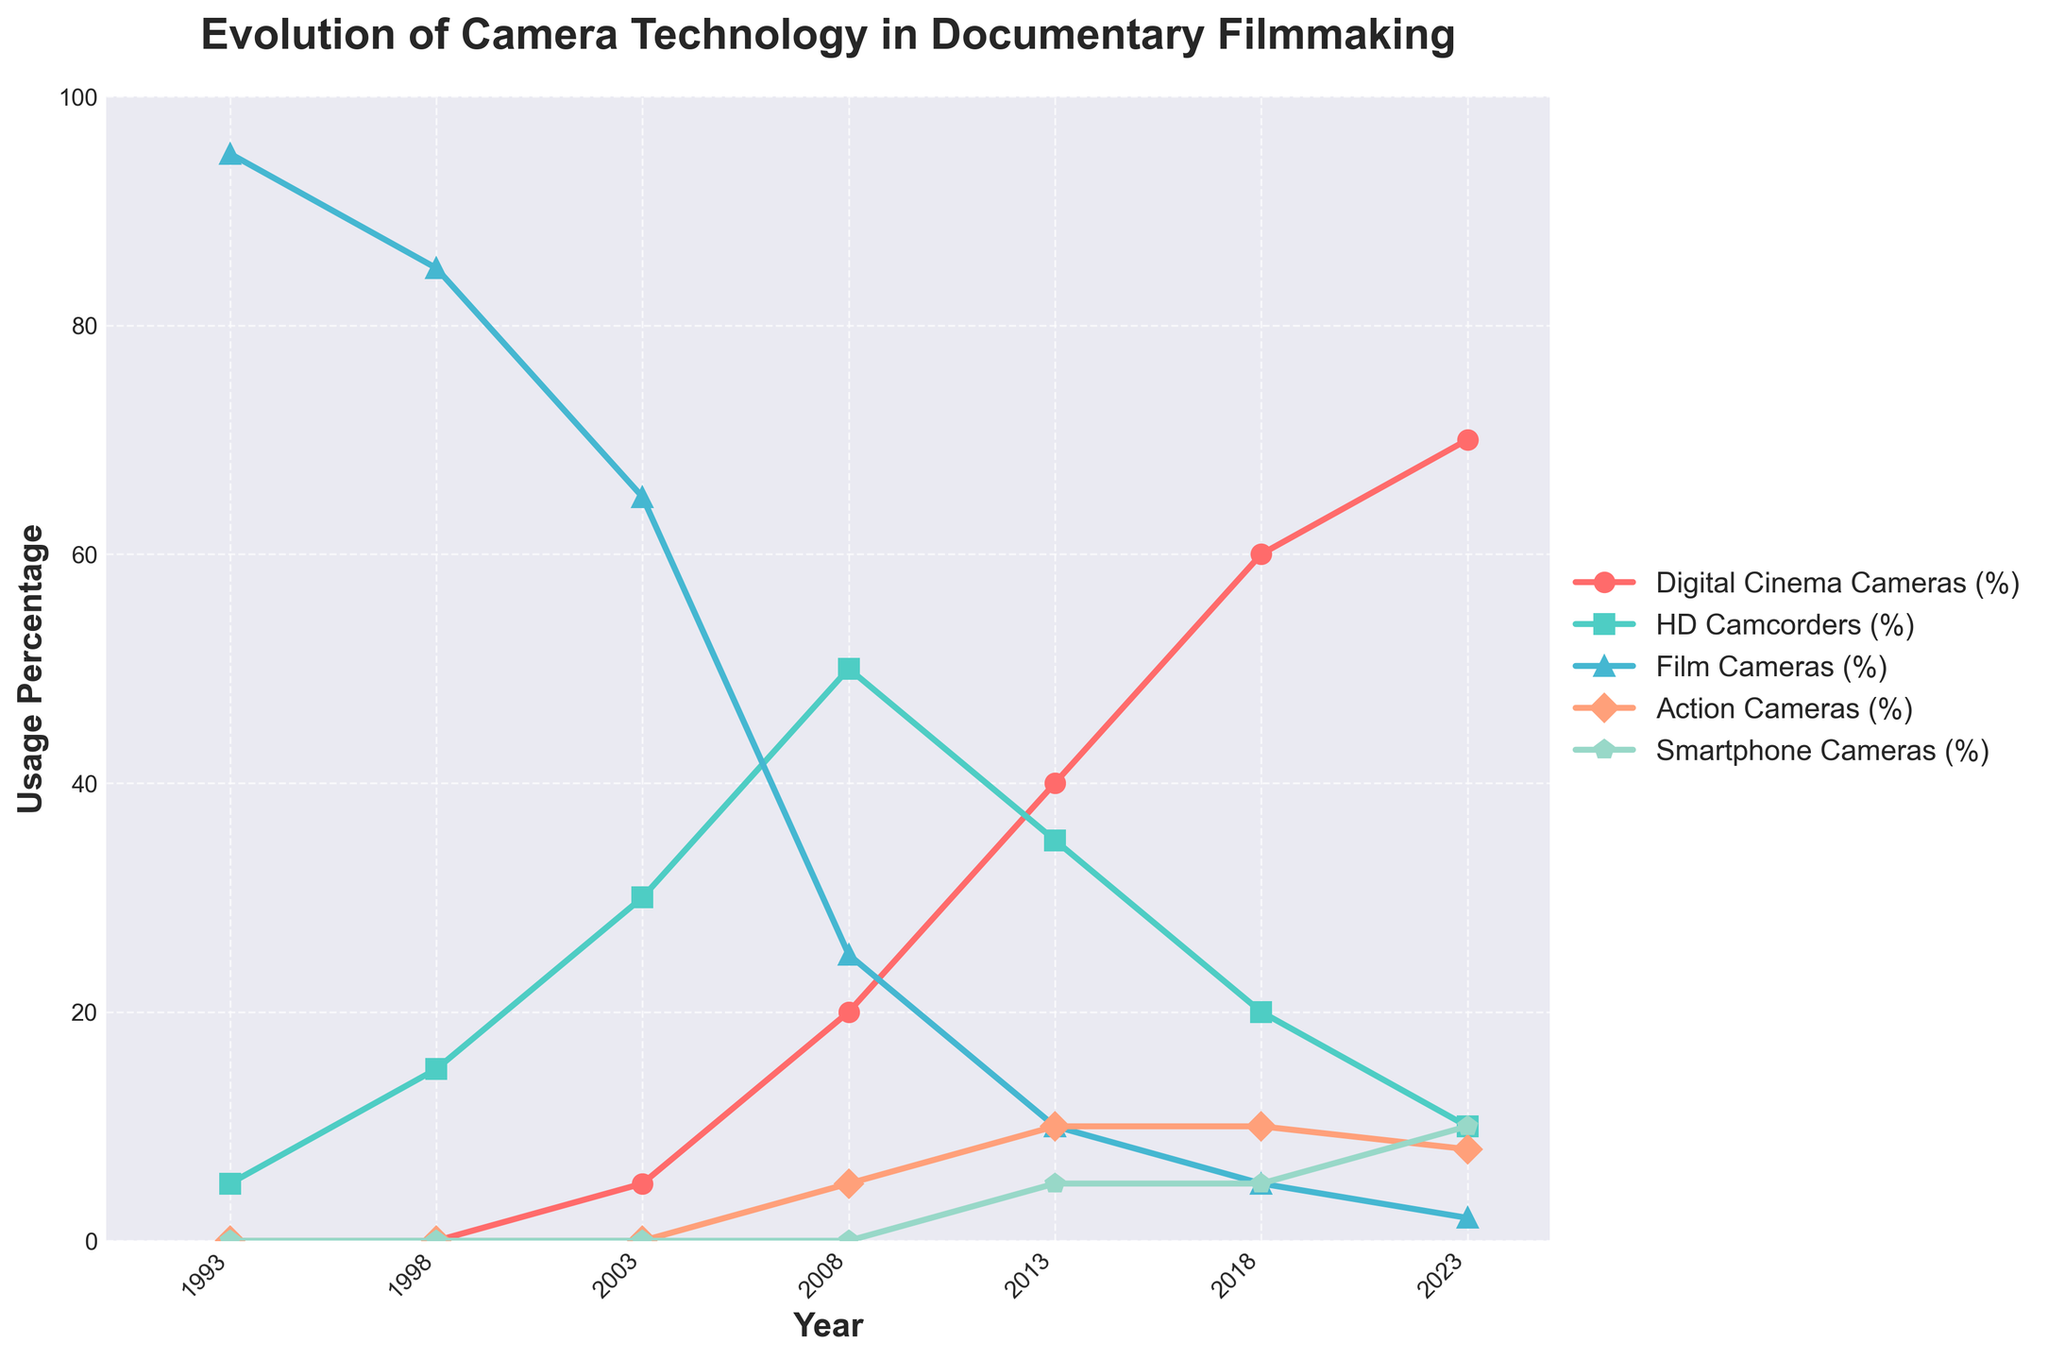Which camera type had the highest usage in 1993? In 1993, the highest line on the chart corresponds to Film Cameras, indicating they had the highest usage.
Answer: Film Cameras How did the percentage of Digital Cinema Cameras change from 2003 to 2023? In 2003, Digital Cinema Cameras had a 5% usage. By 2023, this had increased to 70%, showing a 65% increase.
Answer: Increased by 65% What were the two most used camera technologies in 2018? In 2018, the lines for Digital Cinema Cameras and HD Camcorders are highest, showing 60% and 20% usage, respectively.
Answer: Digital Cinema Cameras and HD Camcorders Which camera type saw the biggest decrease in usage from 1993 to 2023? The line for Film Cameras, starting at 95% in 1993 and dropping to 2% in 2023, indicates the biggest decrease.
Answer: Film Cameras What is the combined usage percentage of Smartphone Cameras and Action Cameras in 2023? By visually adding the 10% of Smartphone Cameras and 8% of Action Cameras in 2023, the combined usage is 18%.
Answer: 18% Which camera type became prevalent after 2010? The line for Digital Cinema Cameras shows a steady increase in usage becoming more prominent after 2010.
Answer: Digital Cinema Cameras Did HD Camcorders ever surpass Film Cameras in usage? Yes, in 2003, HD Camcorders were at 30%, surpassing Film Cameras' 25%.
Answer: Yes How many camera types were used in 2008? Observing the lines at the 2008 mark, it includes Digital Cinema Cameras, HD Camcorders, Film Cameras, and Action Cameras, totaling 4 types.
Answer: 4 What's the trend for Action Cameras from their introduction to 2023? Action Cameras appeared in 2008 with 5% usage, increased to 10% by 2013, stayed at 10% in 2018, and slightly decreased to 8% by 2023, showing an initial increase followed by stabilization and slight decrease.
Answer: Initial increase, then stabilization, slight decrease 